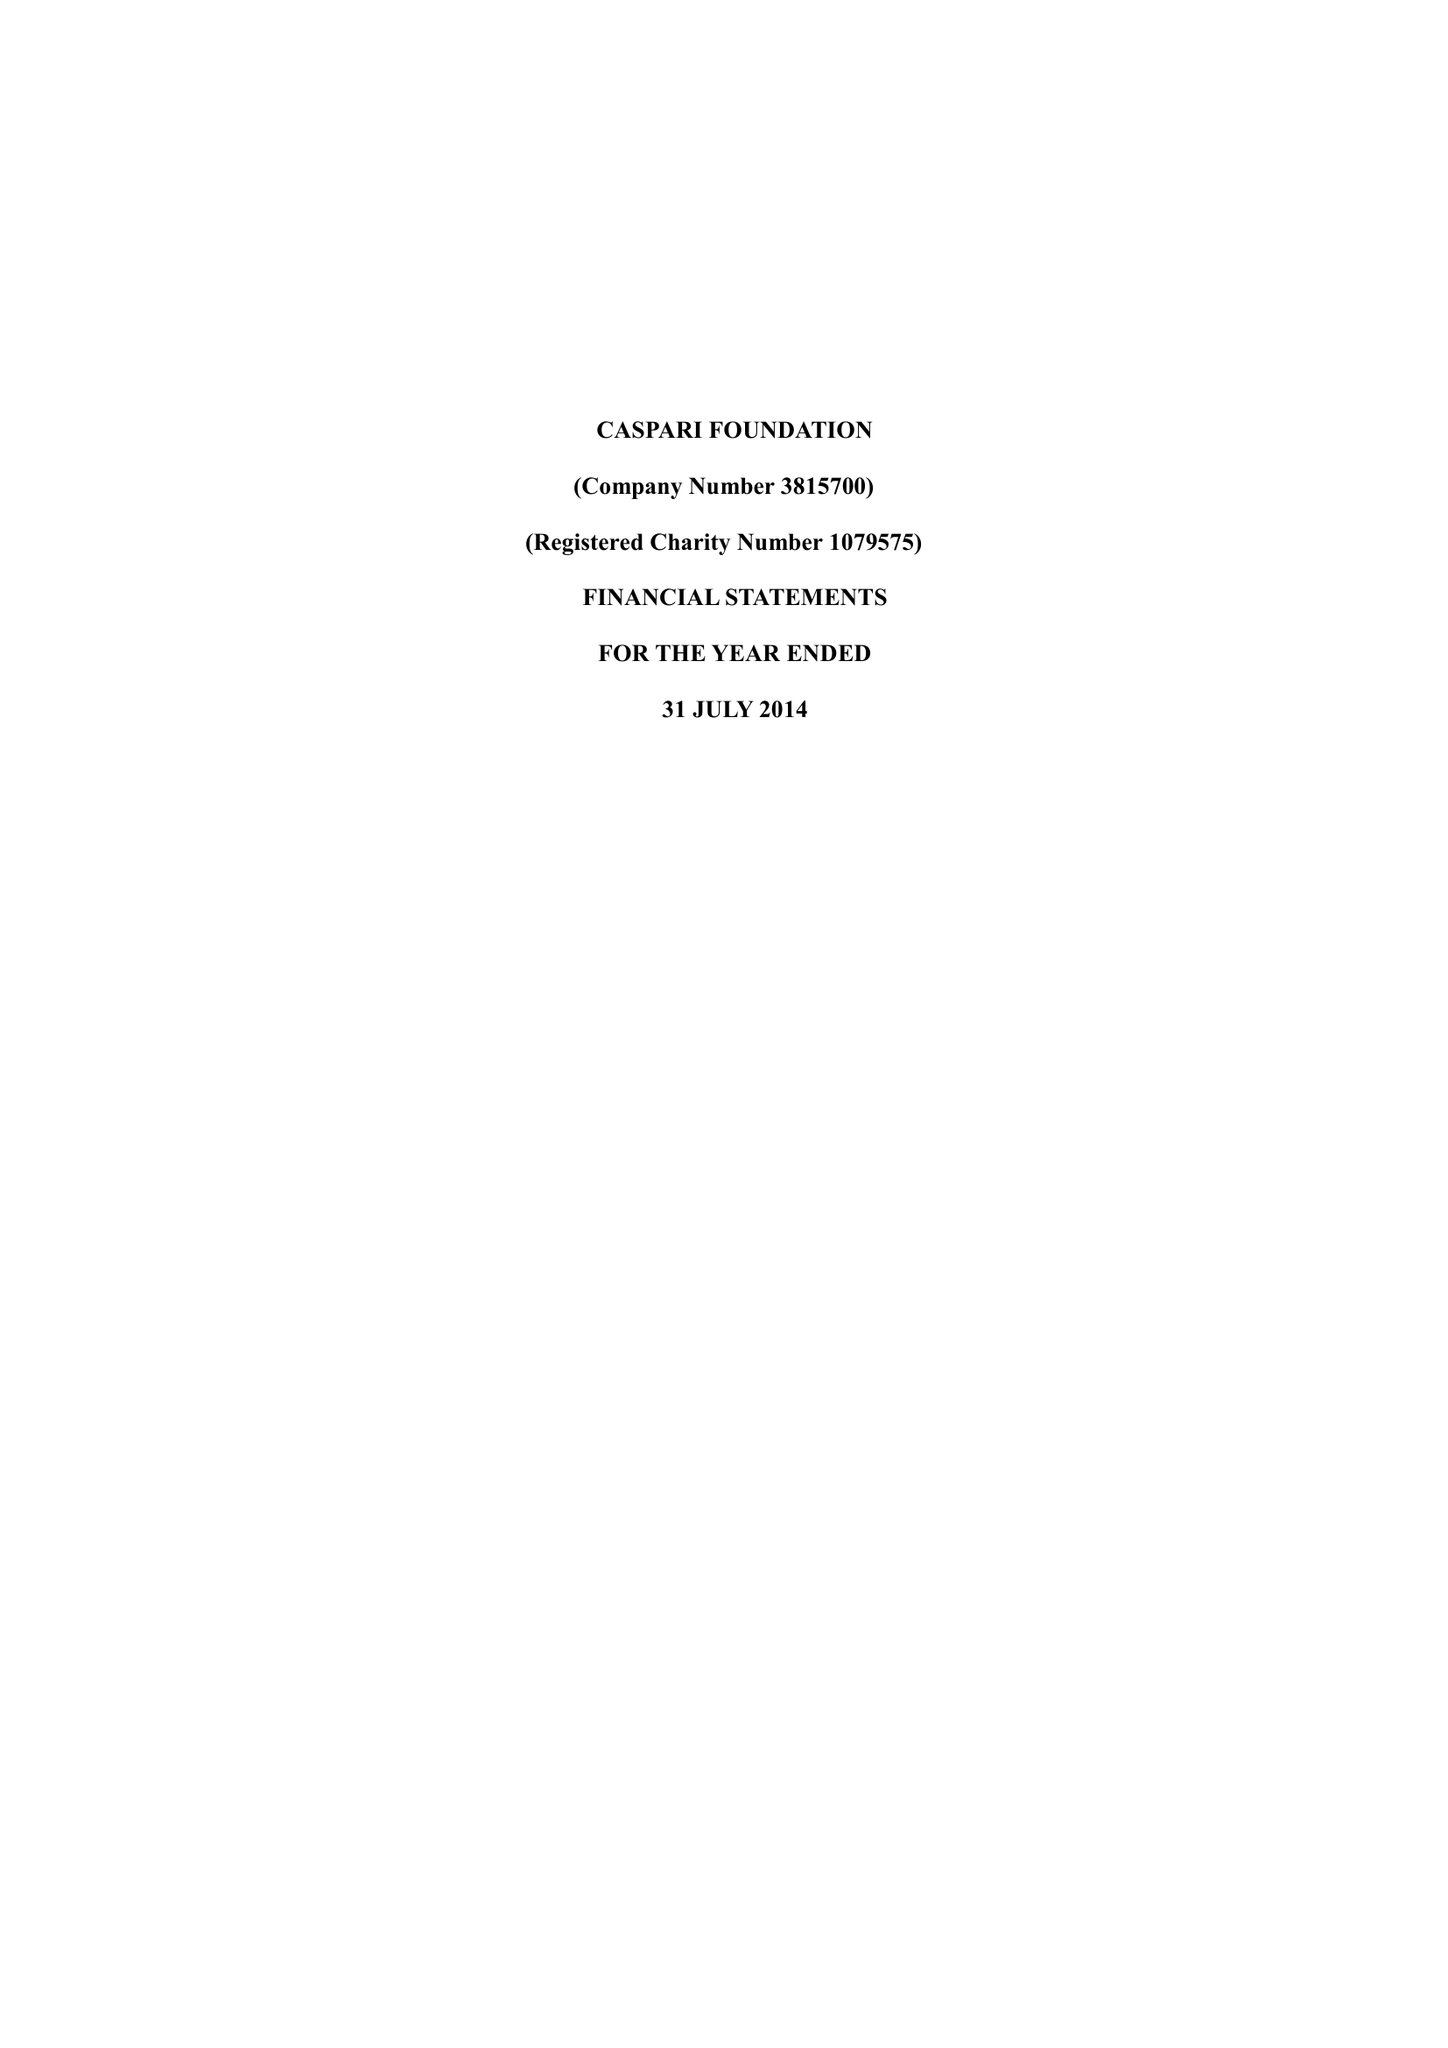What is the value for the income_annually_in_british_pounds?
Answer the question using a single word or phrase. 169825.00 